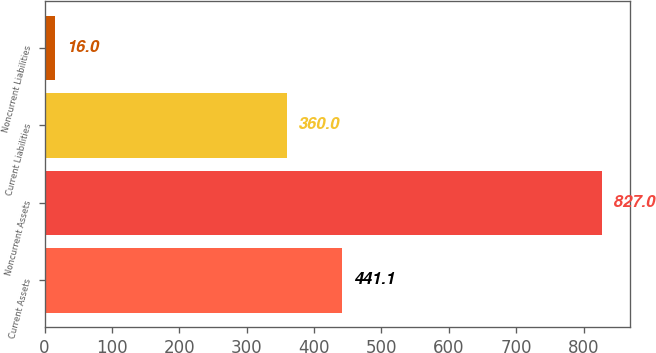Convert chart. <chart><loc_0><loc_0><loc_500><loc_500><bar_chart><fcel>Current Assets<fcel>Noncurrent Assets<fcel>Current Liabilities<fcel>Noncurrent Liabilities<nl><fcel>441.1<fcel>827<fcel>360<fcel>16<nl></chart> 